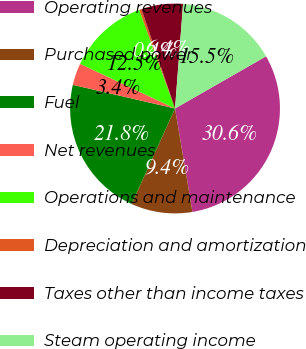Convert chart to OTSL. <chart><loc_0><loc_0><loc_500><loc_500><pie_chart><fcel>Operating revenues<fcel>Purchased power<fcel>Fuel<fcel>Net revenues<fcel>Operations and maintenance<fcel>Depreciation and amortization<fcel>Taxes other than income taxes<fcel>Steam operating income<nl><fcel>30.63%<fcel>9.44%<fcel>21.83%<fcel>3.38%<fcel>12.46%<fcel>0.35%<fcel>6.41%<fcel>15.49%<nl></chart> 